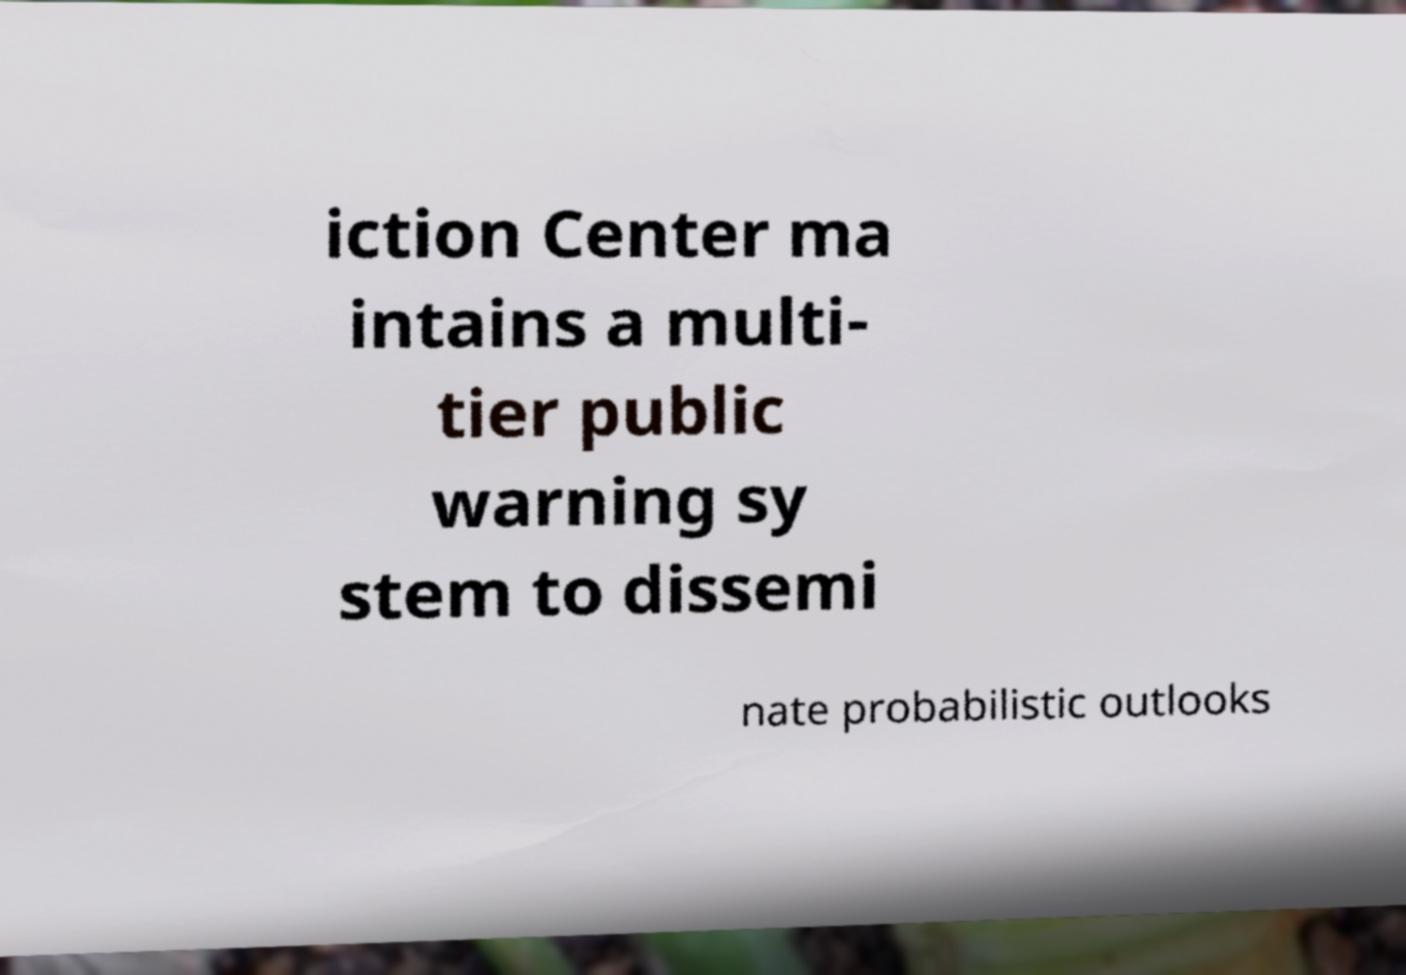Could you assist in decoding the text presented in this image and type it out clearly? iction Center ma intains a multi- tier public warning sy stem to dissemi nate probabilistic outlooks 